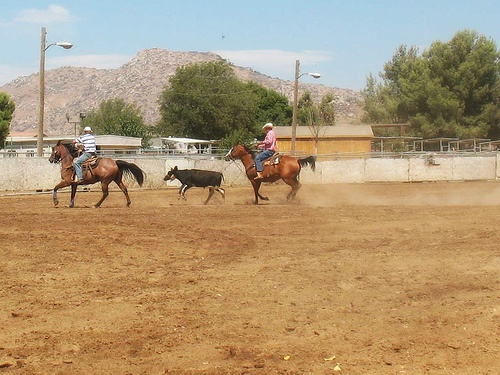Describe the objects in this image and their specific colors. I can see horse in lightblue, black, maroon, and gray tones, horse in lightblue, maroon, brown, and gray tones, cow in lightblue, black, maroon, and tan tones, people in lightblue, white, darkgray, and gray tones, and people in lightblue, gray, lightpink, brown, and maroon tones in this image. 